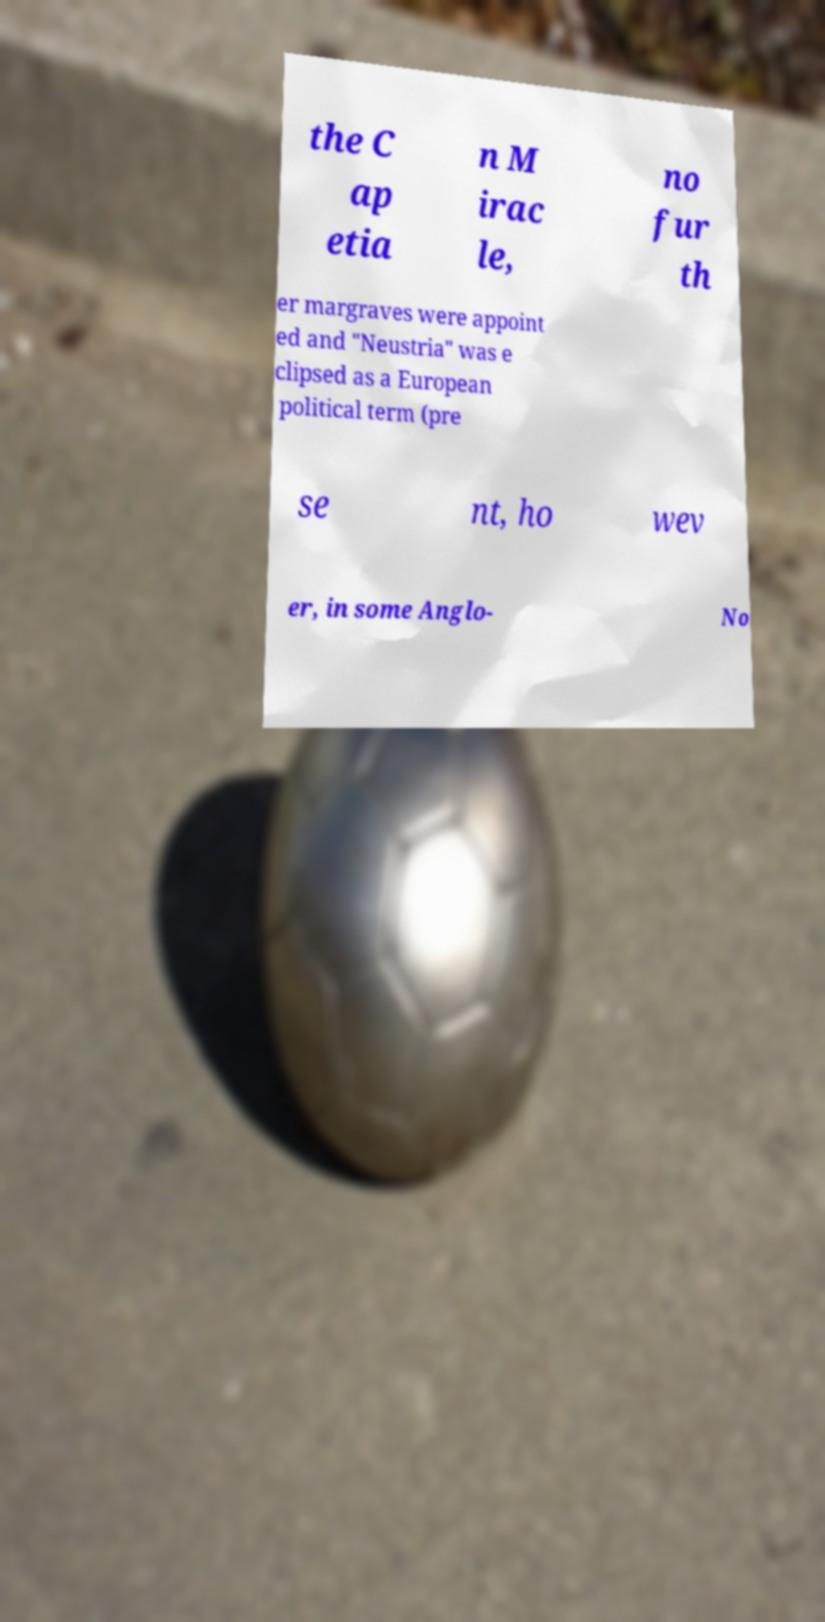Please identify and transcribe the text found in this image. the C ap etia n M irac le, no fur th er margraves were appoint ed and "Neustria" was e clipsed as a European political term (pre se nt, ho wev er, in some Anglo- No 